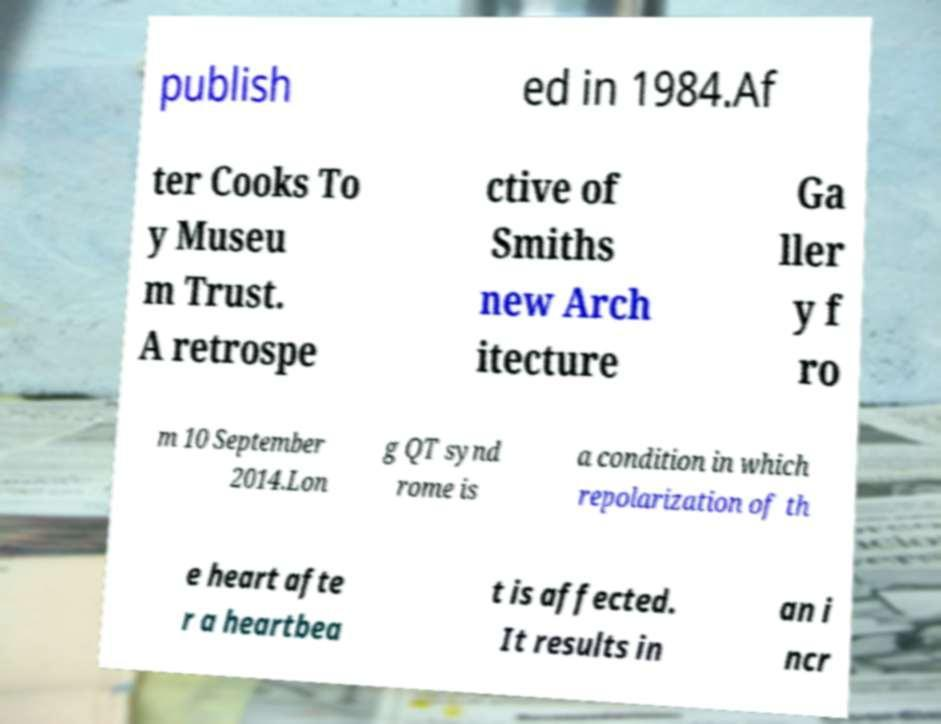Could you assist in decoding the text presented in this image and type it out clearly? publish ed in 1984.Af ter Cooks To y Museu m Trust. A retrospe ctive of Smiths new Arch itecture Ga ller y f ro m 10 September 2014.Lon g QT synd rome is a condition in which repolarization of th e heart afte r a heartbea t is affected. It results in an i ncr 